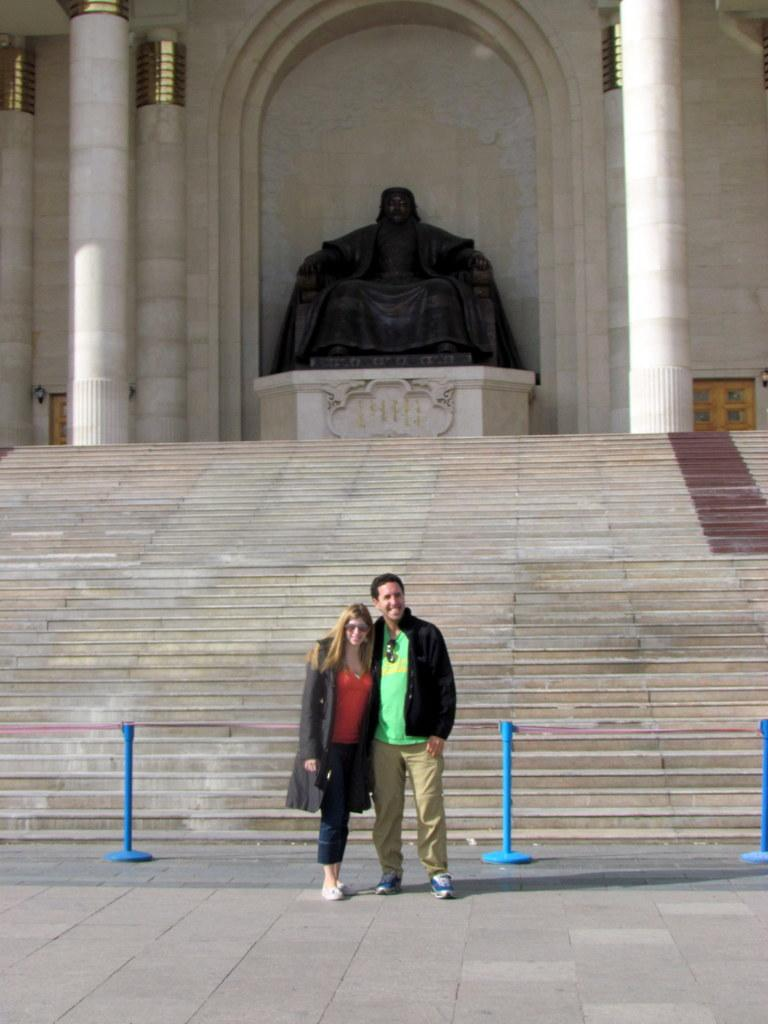How many people are present in the image? There are two people, a man and a woman, present in the image. Where are the man and woman located in the image? Both the man and woman are standing on the road in the image. What objects can be seen in the image related to traffic control or safety? There is a rope and a pole barrier in the image. Can you describe any architectural features in the image? There are steps, a statue on a platform, pillars, a door, and a wall present in the image. What type of boot can be seen on the coast in the image? There is no boot or coast present in the image. What type of school can be seen in the background of the image? There is no school visible in the image. 